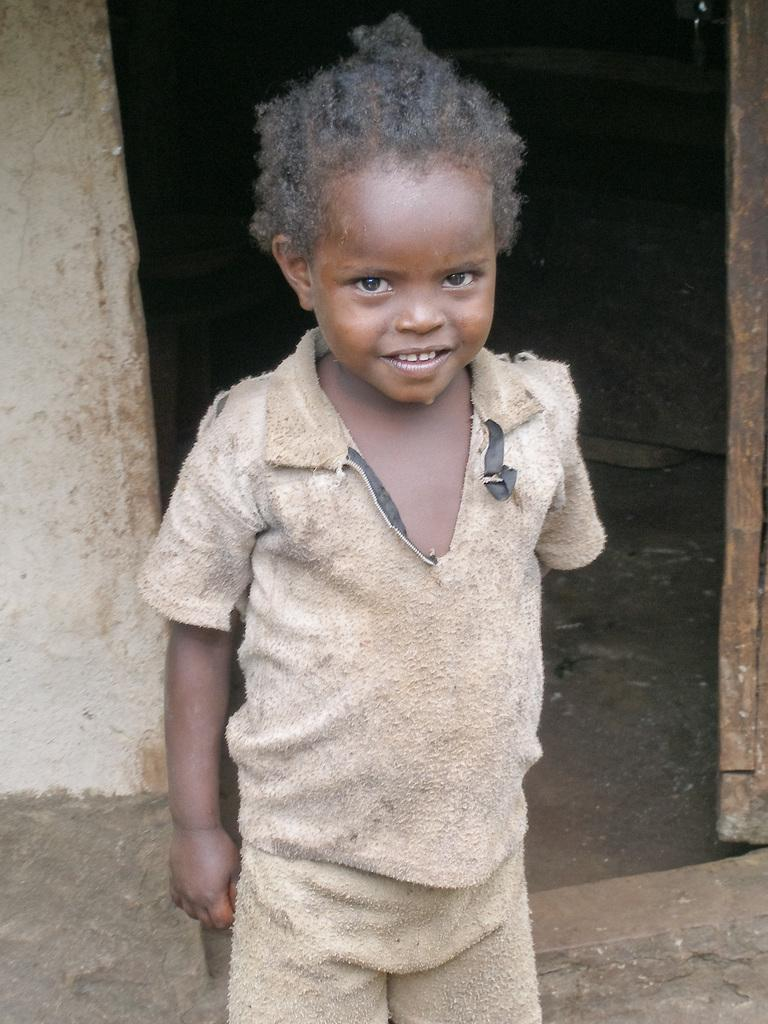What is the main subject of the image? The main subject of the image is a child. What is the child doing in the image? The child is standing and smiling. What can be seen behind the child in the image? There is a wall in the image. What is visible beneath the child in the image? The ground is visible in the image. How would you describe the lighting in the image? The background of the image is dark. What type of pump can be seen in the image? There is no pump present in the image. Is the child taking a bath in the tub in the image? There is no tub or bathing scene depicted in the image. 